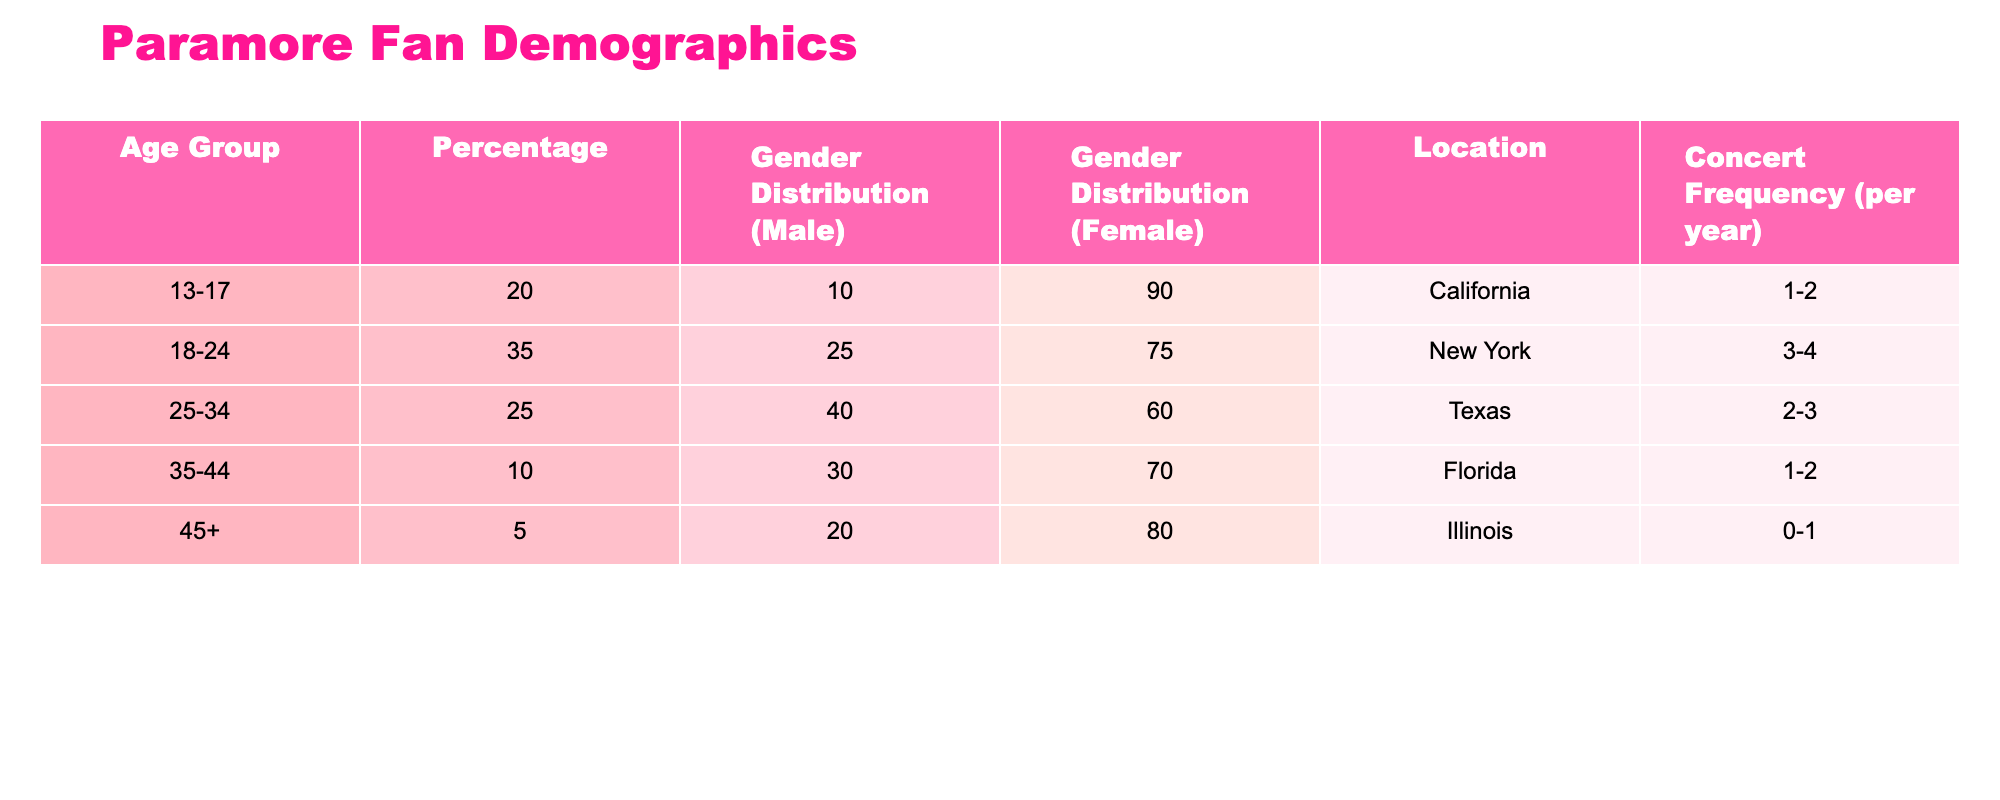What age group constitutes the largest percentage of Paramore fans? Referring to the table, the age group "18-24" has the highest percentage at 35%.
Answer: 18-24 What is the gender distribution of fans aged 25-34? For the age group 25-34, the table shows that 40% are male and 60% are female.
Answer: 40% male, 60% female How many fans aged 45 and above attend concerts frequently (0-1 times per year)? The age group 45+ has a concert frequency of 0-1 times per year, which corresponds to their percentage of 5%, indicating that few fans in this age group attend often.
Answer: 5% Which age group has the highest percentage of male fans? By checking the gender distribution for all age groups, the 25-34 age group has the highest male percentage at 40%.
Answer: 25-34 What is the average concert frequency (per year) for fans aged 18-24 and 25-34? The concert frequency per year for 18-24 is 3-4 (averaging 3.5), and for 25-34, it's 2-3 (averaging 2.5). To find the average: (3.5 + 2.5) / 2 = 3.
Answer: 3 Is it true that fans aged 35-44 make up more than 10% of the fan base? The table shows that fans aged 35-44 constitute only 10% of the fan base, so it is not true.
Answer: No What percentage of female fans come from the age group 13-17? The table indicates that in the age group 13-17, female fans account for 90% of that group's composition.
Answer: 90% What is the difference in the percentage of male fans between the age groups 13-17 and 45+? The percentage of male fans in 13-17 is 10%, and for 45+, it is 20%. The difference is calculated as 20% - 10% = 10%.
Answer: 10% Which location has the highest percentage of fans in the age group 18-24? The table shows that New York, associated with the 18-24 age group, has the highest percentage of 35%.
Answer: New York What is the total percentage of fans aged 35 and above? The total percentage of fans aged 35 and above is calculated by adding the percentages of the age groups 35-44 (10%) and 45+ (5%), which results in 10% + 5% = 15%.
Answer: 15% 